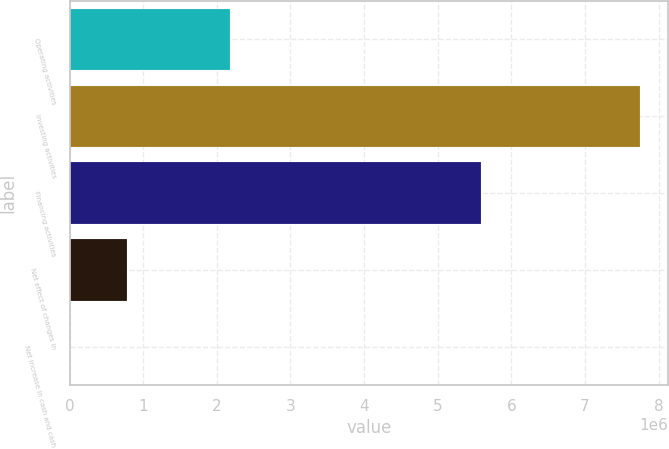Convert chart. <chart><loc_0><loc_0><loc_500><loc_500><bar_chart><fcel>Operating activities<fcel>Investing activities<fcel>Financing activities<fcel>Net effect of changes in<fcel>Net increase in cash and cash<nl><fcel>2.18305e+06<fcel>7.74174e+06<fcel>5.5891e+06<fcel>780648<fcel>7194<nl></chart> 